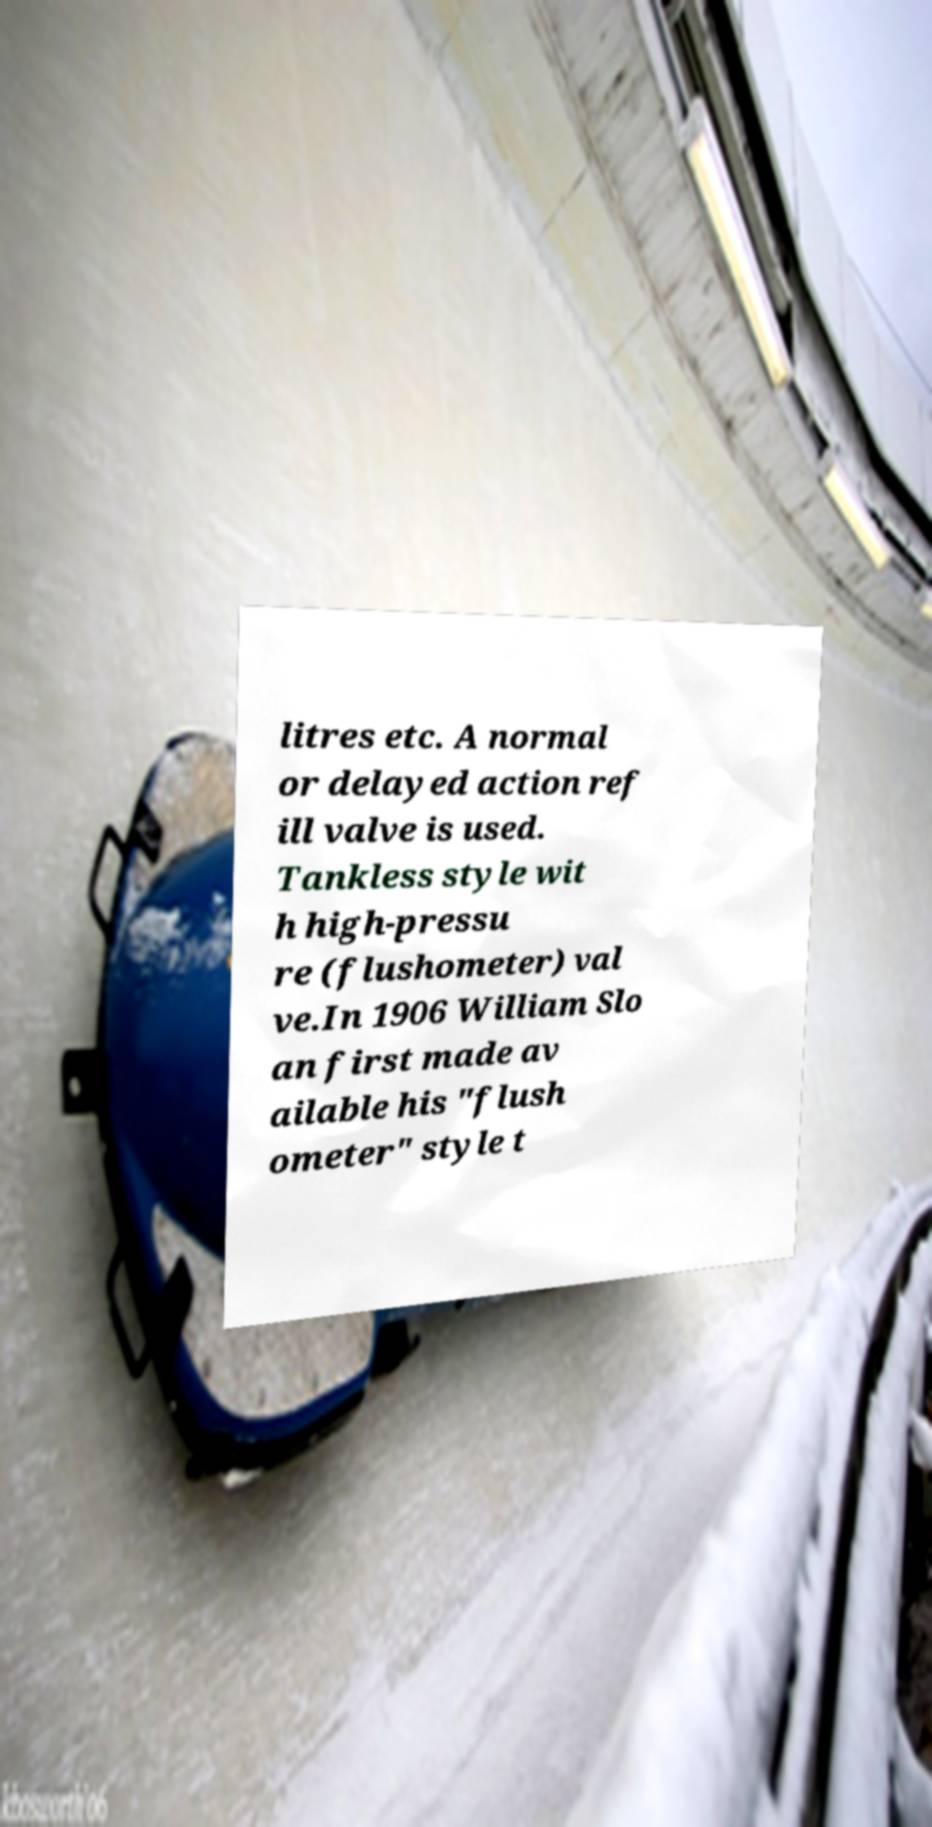Could you assist in decoding the text presented in this image and type it out clearly? litres etc. A normal or delayed action ref ill valve is used. Tankless style wit h high-pressu re (flushometer) val ve.In 1906 William Slo an first made av ailable his "flush ometer" style t 